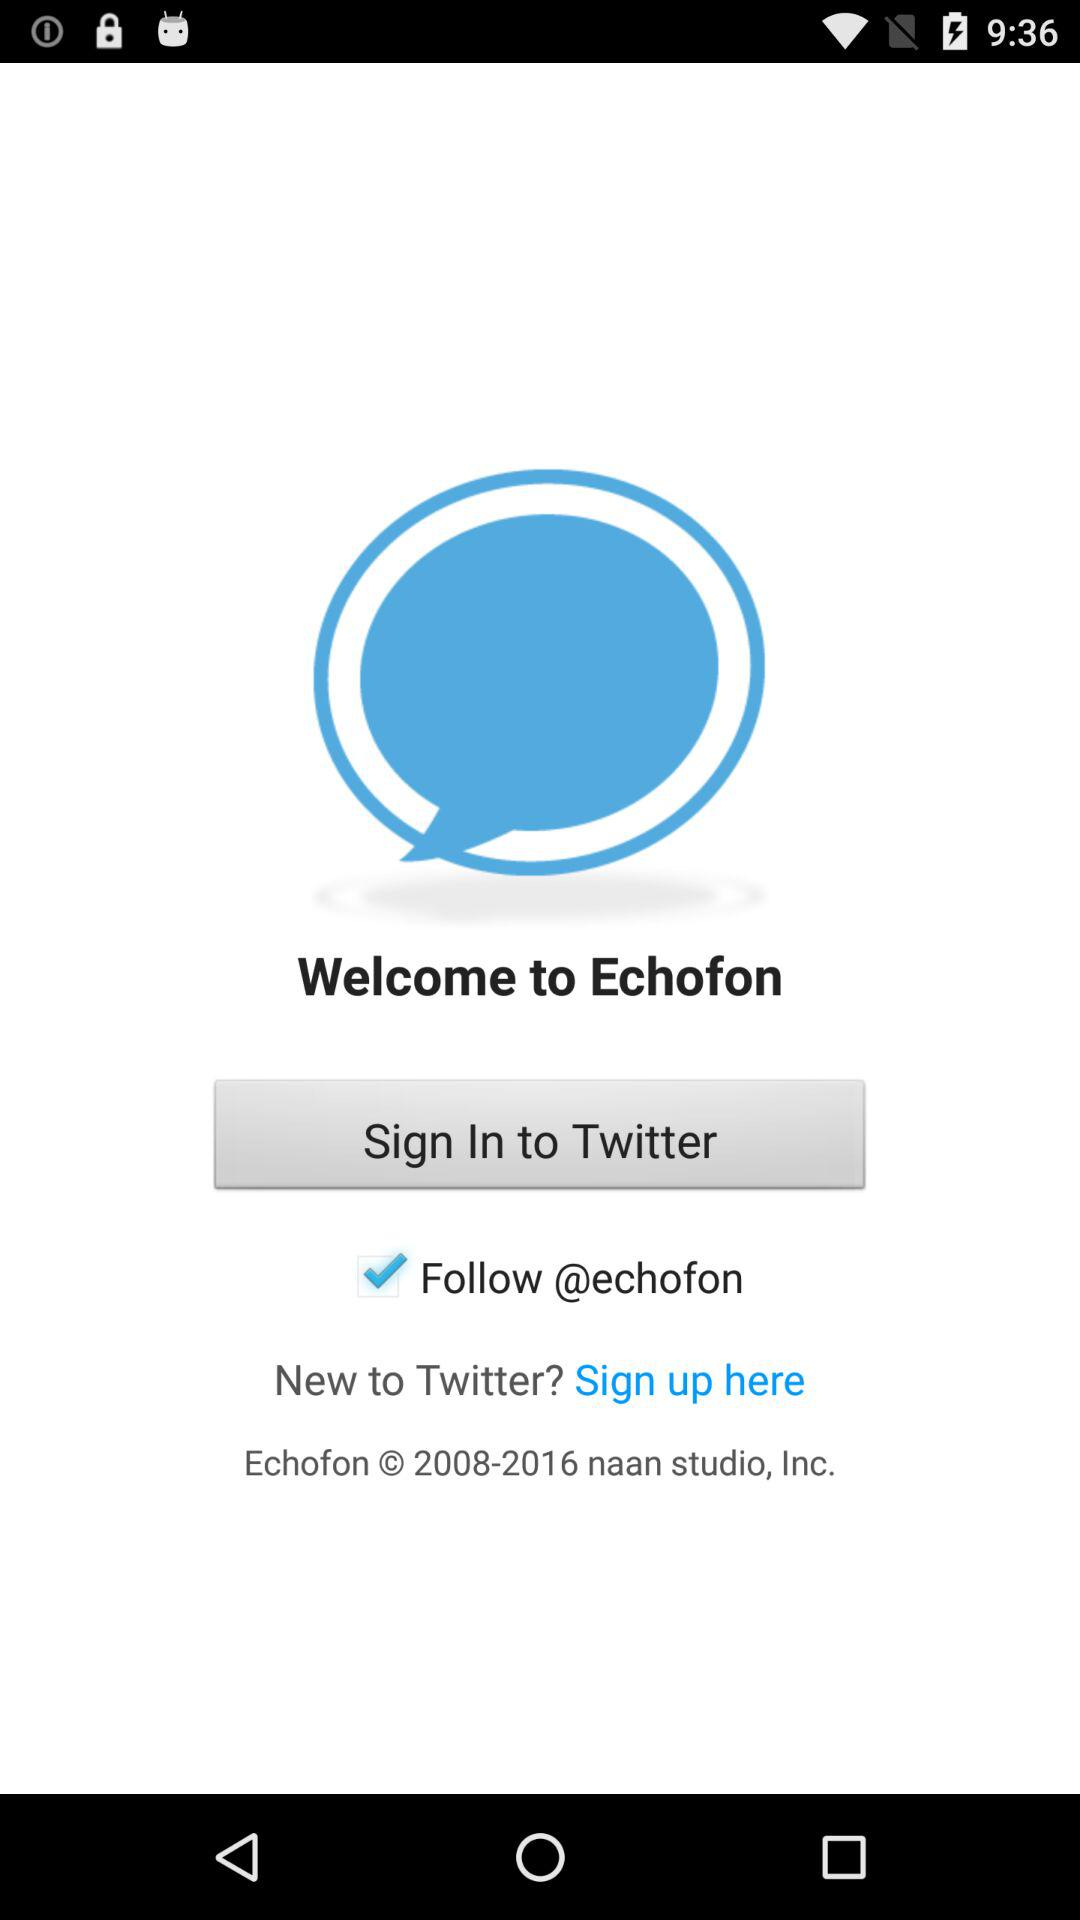Through what application can we sign in? You can sign in through "Twitter". 